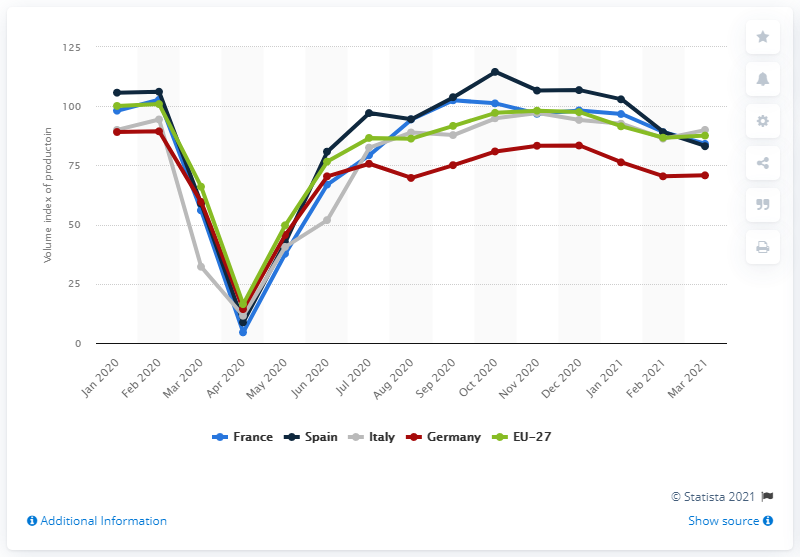Draw attention to some important aspects in this diagram. According to the volume index of the motor vehicle manufacturing industry across the 27 European member states in April 2020, the volume of production in this industry was 16.4. 